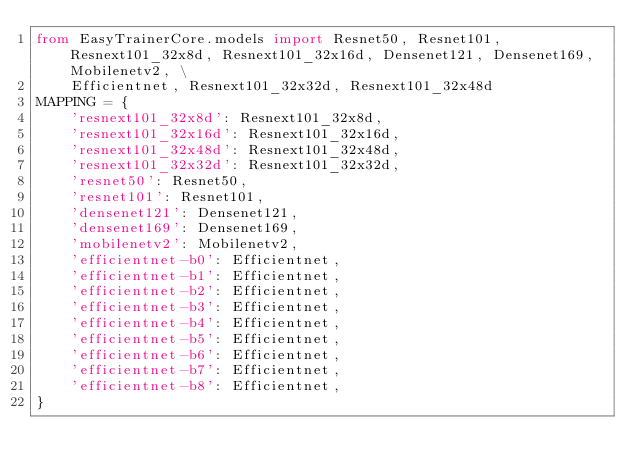Convert code to text. <code><loc_0><loc_0><loc_500><loc_500><_Python_>from EasyTrainerCore.models import Resnet50, Resnet101, Resnext101_32x8d, Resnext101_32x16d, Densenet121, Densenet169, Mobilenetv2, \
    Efficientnet, Resnext101_32x32d, Resnext101_32x48d
MAPPING = {
    'resnext101_32x8d': Resnext101_32x8d,
    'resnext101_32x16d': Resnext101_32x16d,
    'resnext101_32x48d': Resnext101_32x48d,
    'resnext101_32x32d': Resnext101_32x32d,
    'resnet50': Resnet50,
    'resnet101': Resnet101,
    'densenet121': Densenet121,
    'densenet169': Densenet169,
    'mobilenetv2': Mobilenetv2,
    'efficientnet-b0': Efficientnet,
    'efficientnet-b1': Efficientnet,
    'efficientnet-b2': Efficientnet,
    'efficientnet-b3': Efficientnet,
    'efficientnet-b4': Efficientnet,
    'efficientnet-b5': Efficientnet,
    'efficientnet-b6': Efficientnet,
    'efficientnet-b7': Efficientnet,
    'efficientnet-b8': Efficientnet,
}



</code> 